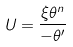<formula> <loc_0><loc_0><loc_500><loc_500>U = \frac { \xi \theta ^ { n } } { - \theta ^ { \prime } }</formula> 